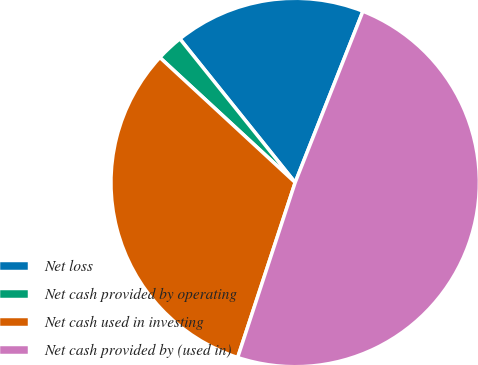<chart> <loc_0><loc_0><loc_500><loc_500><pie_chart><fcel>Net loss<fcel>Net cash provided by operating<fcel>Net cash used in investing<fcel>Net cash provided by (used in)<nl><fcel>16.76%<fcel>2.37%<fcel>31.82%<fcel>49.06%<nl></chart> 